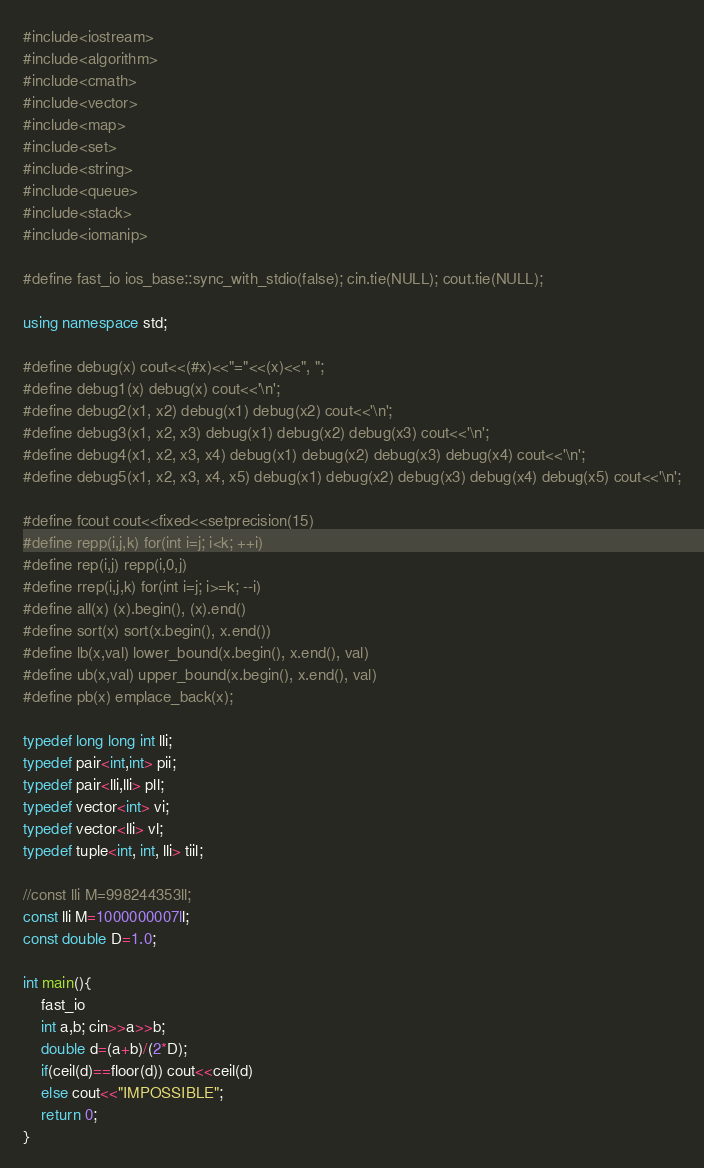<code> <loc_0><loc_0><loc_500><loc_500><_C++_>#include<iostream>
#include<algorithm>
#include<cmath>
#include<vector>
#include<map>
#include<set>
#include<string>
#include<queue>
#include<stack>
#include<iomanip>

#define fast_io ios_base::sync_with_stdio(false); cin.tie(NULL); cout.tie(NULL);

using namespace std;

#define debug(x) cout<<(#x)<<"="<<(x)<<", ";
#define debug1(x) debug(x) cout<<'\n';
#define debug2(x1, x2) debug(x1) debug(x2) cout<<'\n';
#define debug3(x1, x2, x3) debug(x1) debug(x2) debug(x3) cout<<'\n';
#define debug4(x1, x2, x3, x4) debug(x1) debug(x2) debug(x3) debug(x4) cout<<'\n';
#define debug5(x1, x2, x3, x4, x5) debug(x1) debug(x2) debug(x3) debug(x4) debug(x5) cout<<'\n';

#define fcout cout<<fixed<<setprecision(15)
#define repp(i,j,k) for(int i=j; i<k; ++i)
#define rep(i,j) repp(i,0,j)
#define rrep(i,j,k) for(int i=j; i>=k; --i)
#define all(x) (x).begin(), (x).end()
#define sort(x) sort(x.begin(), x.end())
#define lb(x,val) lower_bound(x.begin(), x.end(), val)
#define ub(x,val) upper_bound(x.begin(), x.end(), val)
#define pb(x) emplace_back(x);

typedef long long int lli;
typedef pair<int,int> pii;
typedef pair<lli,lli> pll;
typedef vector<int> vi;
typedef vector<lli> vl;
typedef tuple<int, int, lli> tiil;

//const lli M=998244353ll;
const lli M=1000000007ll;
const double D=1.0;

int main(){
	fast_io
	int a,b; cin>>a>>b;
	double d=(a+b)/(2*D);
	if(ceil(d)==floor(d)) cout<<ceil(d)
	else cout<<"IMPOSSIBLE";
	return 0;
}</code> 